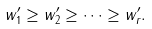<formula> <loc_0><loc_0><loc_500><loc_500>w ^ { \prime } _ { 1 } \geq w ^ { \prime } _ { 2 } \geq \cdots \geq w ^ { \prime } _ { r } .</formula> 